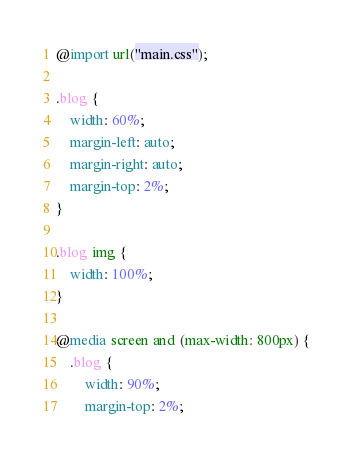<code> <loc_0><loc_0><loc_500><loc_500><_CSS_>@import url("main.css");

.blog {
    width: 60%;
    margin-left: auto;
    margin-right: auto;
    margin-top: 2%;
}

.blog img {
    width: 100%;
}

@media screen and (max-width: 800px) {
    .blog {
        width: 90%;
        margin-top: 2%;</code> 